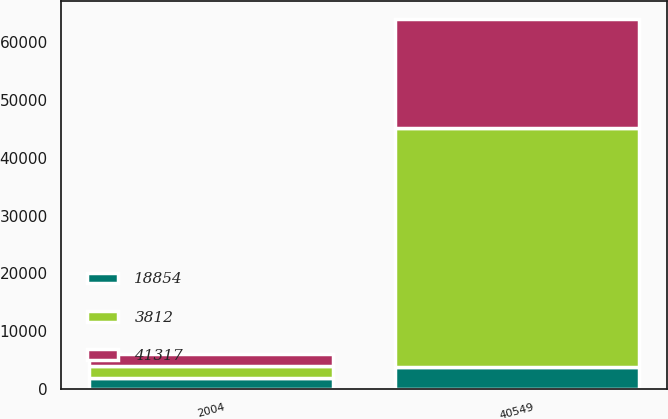Convert chart to OTSL. <chart><loc_0><loc_0><loc_500><loc_500><stacked_bar_chart><ecel><fcel>2004<fcel>40549<nl><fcel>3812<fcel>2003<fcel>41317<nl><fcel>41317<fcel>2002<fcel>18854<nl><fcel>18854<fcel>2001<fcel>3812<nl></chart> 